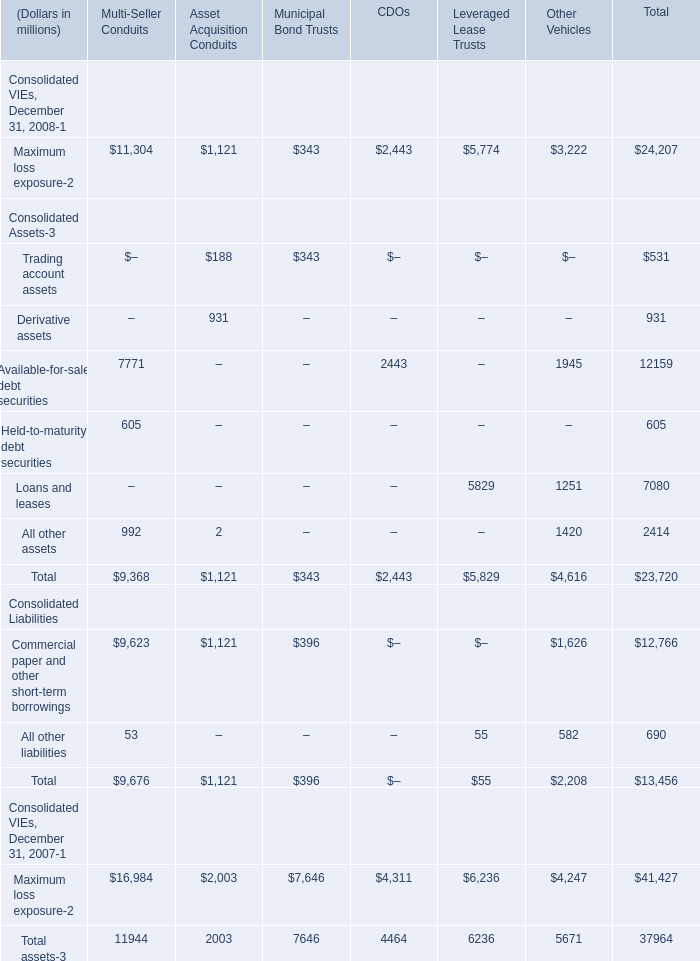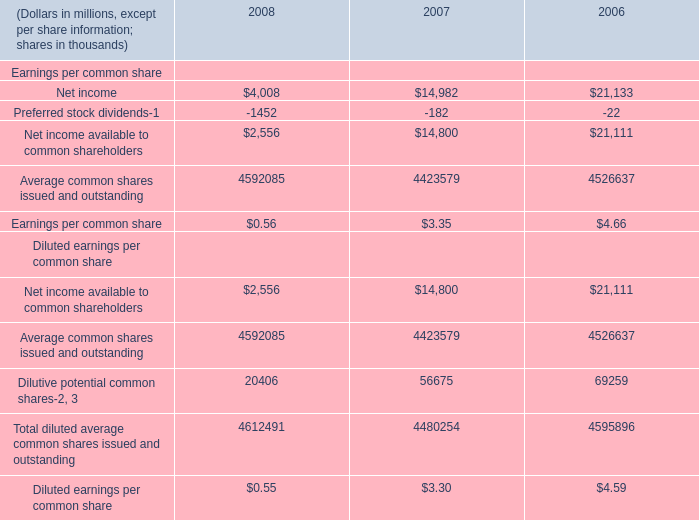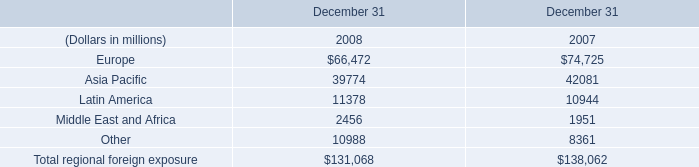what's the total amount of Latin America of December 31 2008, and Loans and leases Consolidated Assets of Other Vehicles ? 
Computations: (11378.0 + 1251.0)
Answer: 12629.0. 